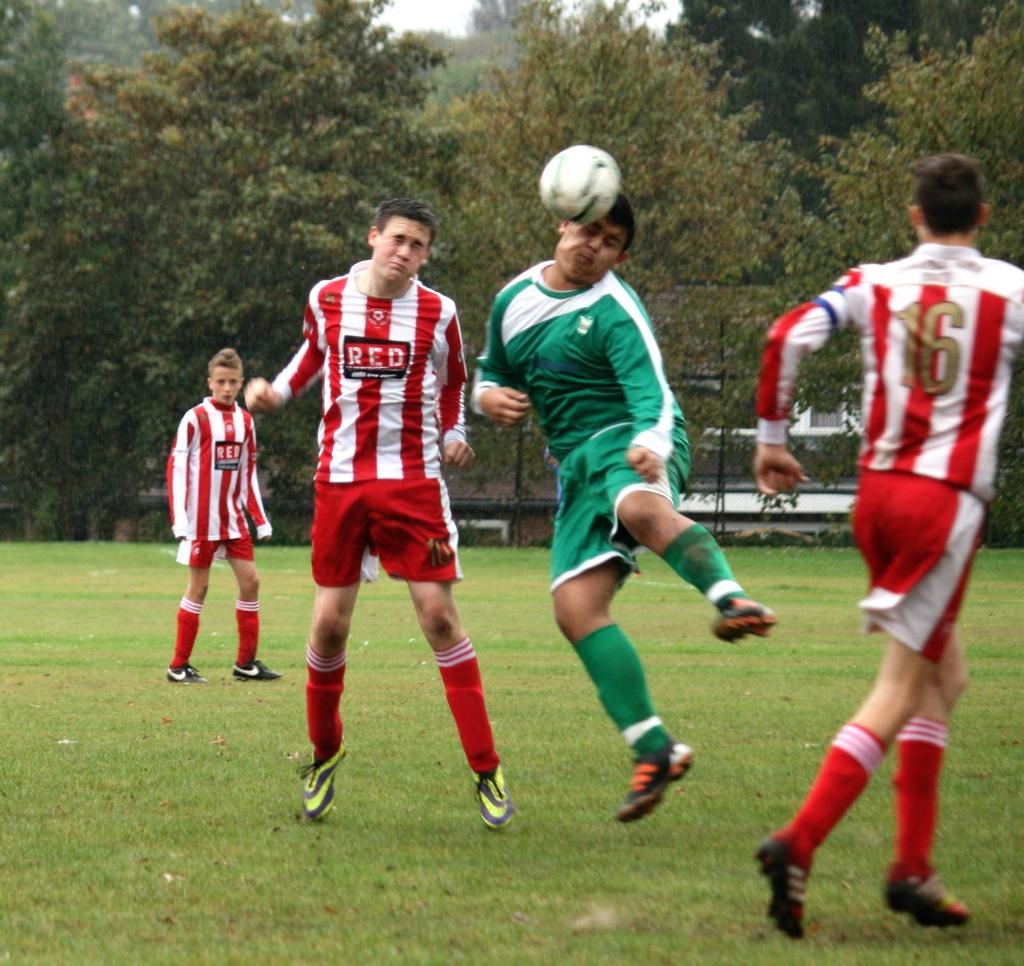In one or two sentences, can you explain what this image depicts? On the background we can see trees. Here we can see four persons playing a game in a ground. This is a fresh green grass. This is a ball. 